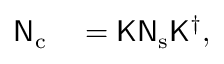Convert formula to latex. <formula><loc_0><loc_0><loc_500><loc_500>\begin{array} { r l } { { \mathsf N } _ { c } } & = { \mathsf K } { \mathsf N } _ { s } { \mathsf K } ^ { \dagger } , } \end{array}</formula> 